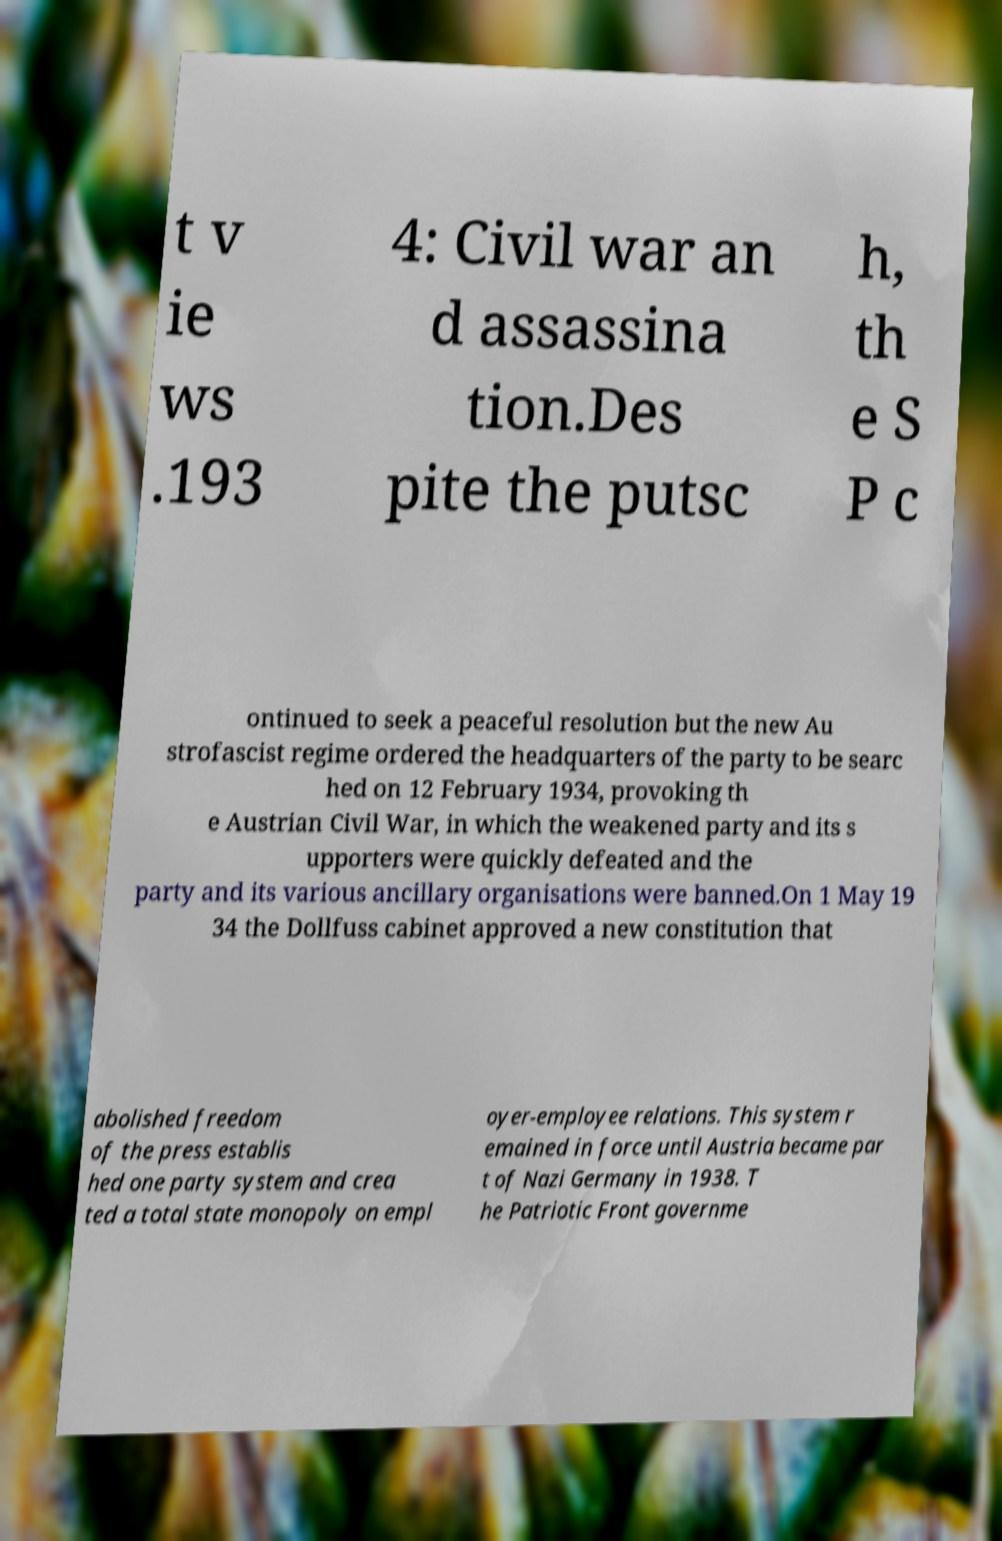I need the written content from this picture converted into text. Can you do that? t v ie ws .193 4: Civil war an d assassina tion.Des pite the putsc h, th e S P c ontinued to seek a peaceful resolution but the new Au strofascist regime ordered the headquarters of the party to be searc hed on 12 February 1934, provoking th e Austrian Civil War, in which the weakened party and its s upporters were quickly defeated and the party and its various ancillary organisations were banned.On 1 May 19 34 the Dollfuss cabinet approved a new constitution that abolished freedom of the press establis hed one party system and crea ted a total state monopoly on empl oyer-employee relations. This system r emained in force until Austria became par t of Nazi Germany in 1938. T he Patriotic Front governme 